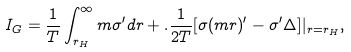<formula> <loc_0><loc_0><loc_500><loc_500>I _ { G } = \frac { 1 } { T } \int _ { r _ { H } } ^ { \infty } m \sigma ^ { \prime } d r + . \frac { 1 } { 2 T } [ \sigma ( m r ) ^ { \prime } - \sigma ^ { \prime } \Delta ] | _ { r = r _ { H } } ,</formula> 